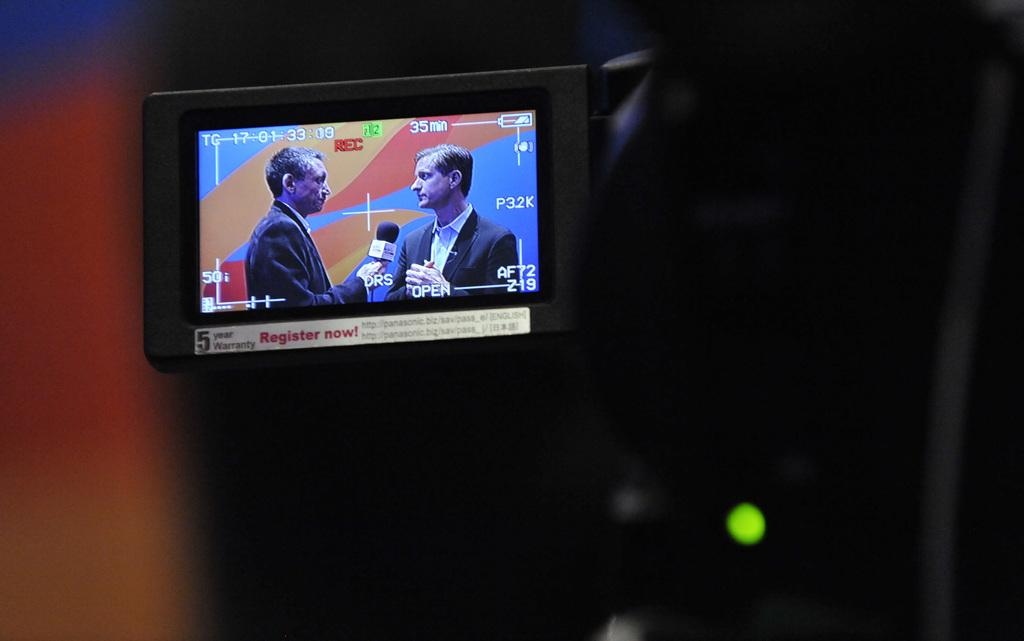<image>
Share a concise interpretation of the image provided. Camera showing a five year warranty and register now ad. 